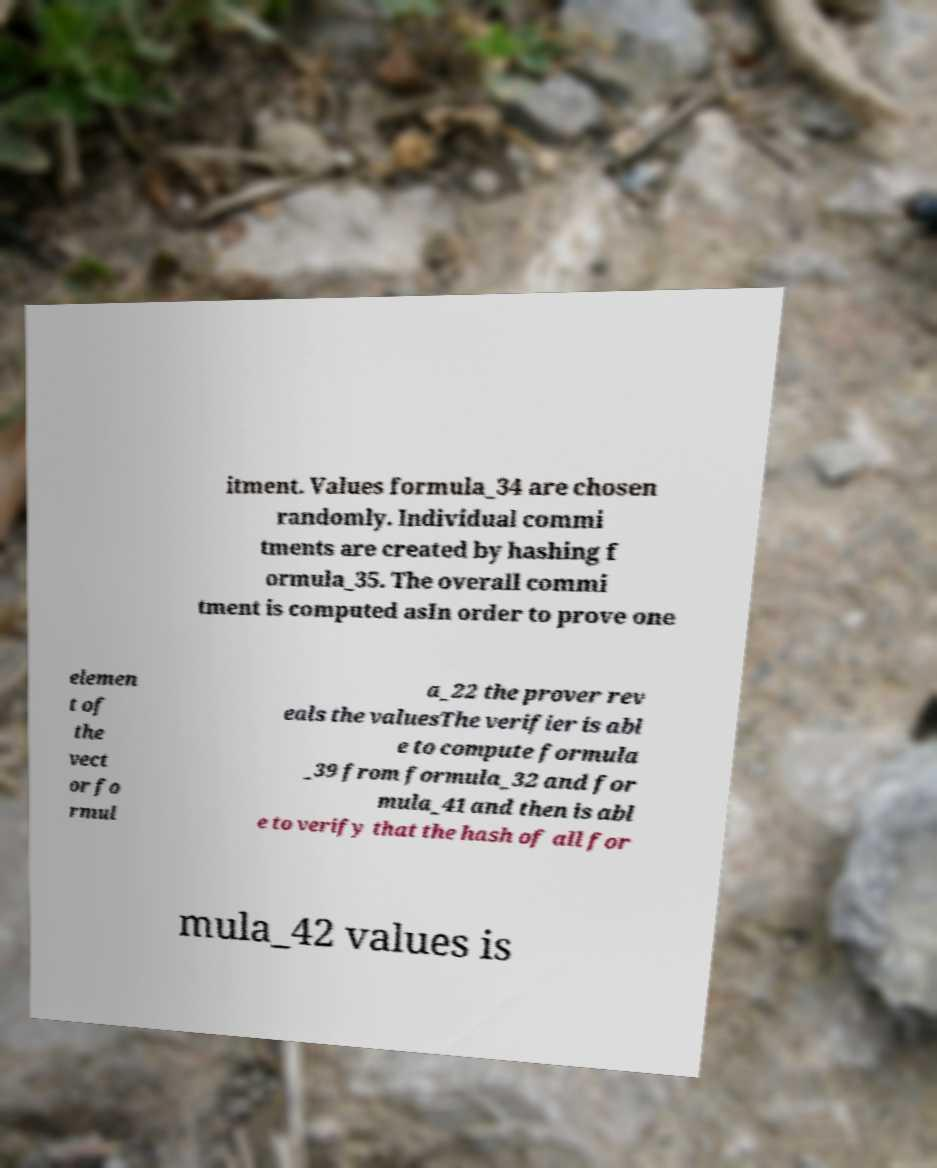For documentation purposes, I need the text within this image transcribed. Could you provide that? itment. Values formula_34 are chosen randomly. Individual commi tments are created by hashing f ormula_35. The overall commi tment is computed asIn order to prove one elemen t of the vect or fo rmul a_22 the prover rev eals the valuesThe verifier is abl e to compute formula _39 from formula_32 and for mula_41 and then is abl e to verify that the hash of all for mula_42 values is 